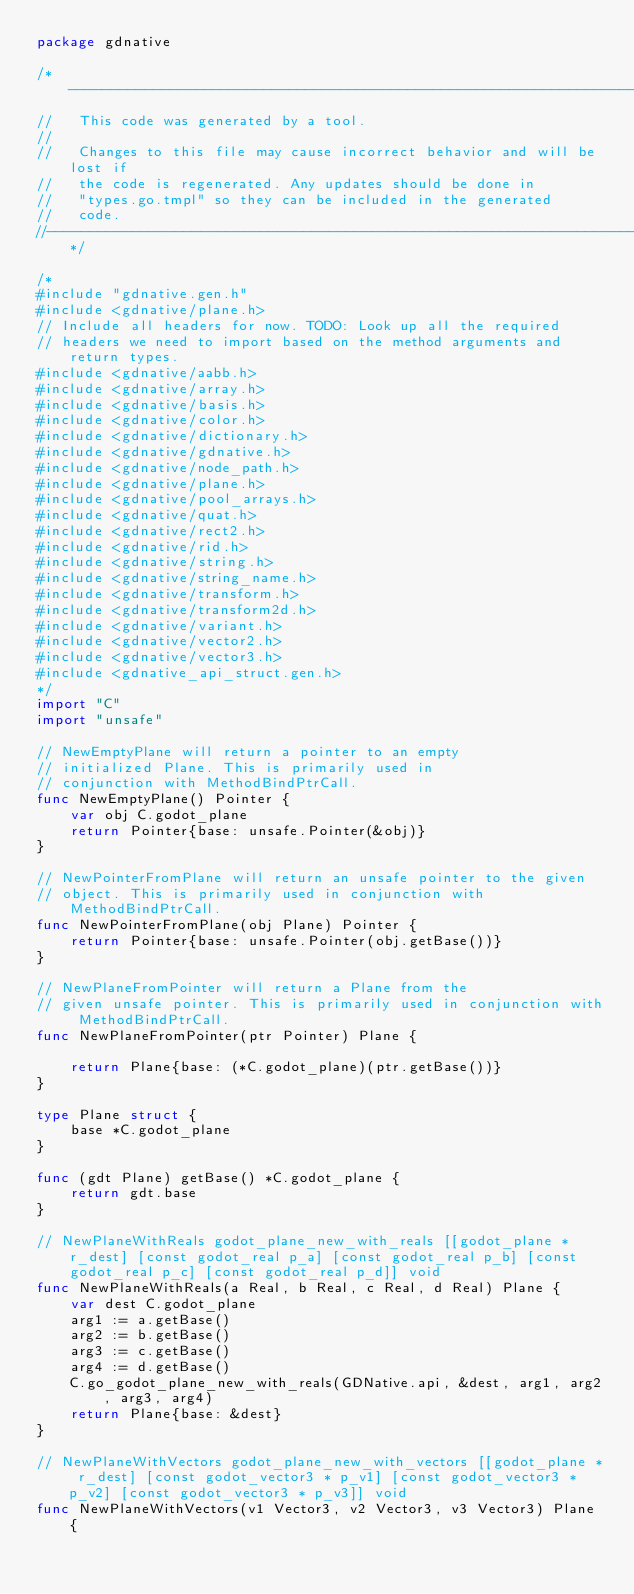<code> <loc_0><loc_0><loc_500><loc_500><_Go_>package gdnative

/*------------------------------------------------------------------------------
//   This code was generated by a tool.
//
//   Changes to this file may cause incorrect behavior and will be lost if
//   the code is regenerated. Any updates should be done in
//   "types.go.tmpl" so they can be included in the generated
//   code.
//----------------------------------------------------------------------------*/

/*
#include "gdnative.gen.h"
#include <gdnative/plane.h>
// Include all headers for now. TODO: Look up all the required
// headers we need to import based on the method arguments and return types.
#include <gdnative/aabb.h>
#include <gdnative/array.h>
#include <gdnative/basis.h>
#include <gdnative/color.h>
#include <gdnative/dictionary.h>
#include <gdnative/gdnative.h>
#include <gdnative/node_path.h>
#include <gdnative/plane.h>
#include <gdnative/pool_arrays.h>
#include <gdnative/quat.h>
#include <gdnative/rect2.h>
#include <gdnative/rid.h>
#include <gdnative/string.h>
#include <gdnative/string_name.h>
#include <gdnative/transform.h>
#include <gdnative/transform2d.h>
#include <gdnative/variant.h>
#include <gdnative/vector2.h>
#include <gdnative/vector3.h>
#include <gdnative_api_struct.gen.h>
*/
import "C"
import "unsafe"

// NewEmptyPlane will return a pointer to an empty
// initialized Plane. This is primarily used in
// conjunction with MethodBindPtrCall.
func NewEmptyPlane() Pointer {
	var obj C.godot_plane
	return Pointer{base: unsafe.Pointer(&obj)}
}

// NewPointerFromPlane will return an unsafe pointer to the given
// object. This is primarily used in conjunction with MethodBindPtrCall.
func NewPointerFromPlane(obj Plane) Pointer {
	return Pointer{base: unsafe.Pointer(obj.getBase())}
}

// NewPlaneFromPointer will return a Plane from the
// given unsafe pointer. This is primarily used in conjunction with MethodBindPtrCall.
func NewPlaneFromPointer(ptr Pointer) Plane {

	return Plane{base: (*C.godot_plane)(ptr.getBase())}
}

type Plane struct {
	base *C.godot_plane
}

func (gdt Plane) getBase() *C.godot_plane {
	return gdt.base
}

// NewPlaneWithReals godot_plane_new_with_reals [[godot_plane * r_dest] [const godot_real p_a] [const godot_real p_b] [const godot_real p_c] [const godot_real p_d]] void
func NewPlaneWithReals(a Real, b Real, c Real, d Real) Plane {
	var dest C.godot_plane
	arg1 := a.getBase()
	arg2 := b.getBase()
	arg3 := c.getBase()
	arg4 := d.getBase()
	C.go_godot_plane_new_with_reals(GDNative.api, &dest, arg1, arg2, arg3, arg4)
	return Plane{base: &dest}
}

// NewPlaneWithVectors godot_plane_new_with_vectors [[godot_plane * r_dest] [const godot_vector3 * p_v1] [const godot_vector3 * p_v2] [const godot_vector3 * p_v3]] void
func NewPlaneWithVectors(v1 Vector3, v2 Vector3, v3 Vector3) Plane {</code> 